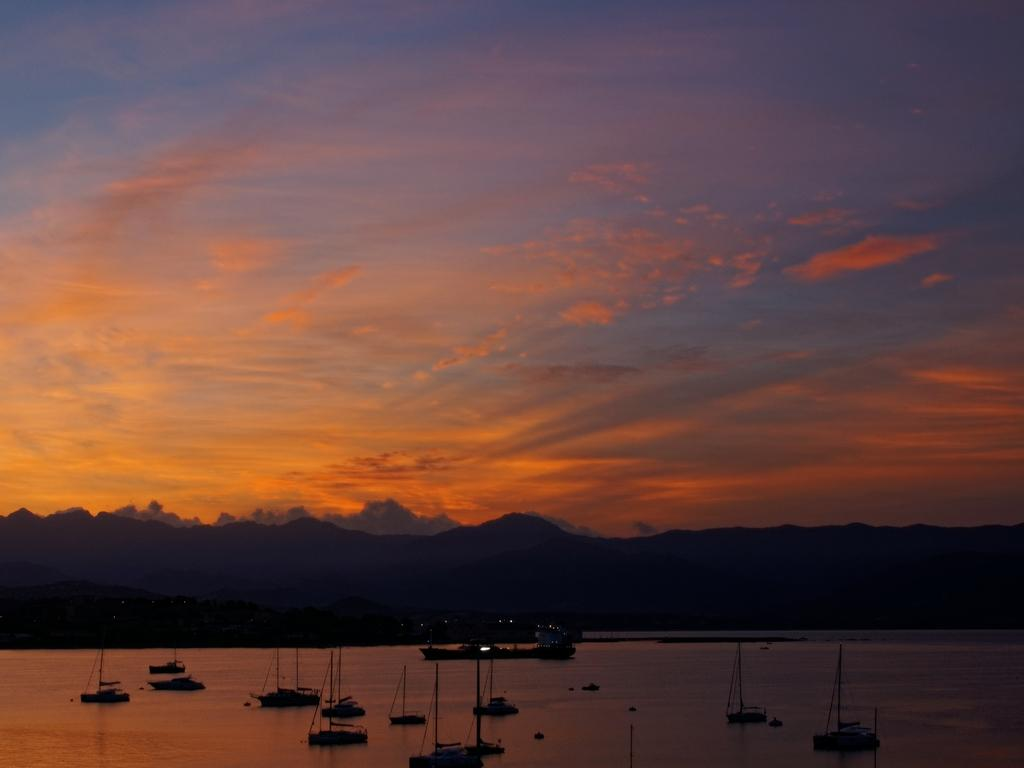What is the main event or scene depicted in the image? The image depicts a sunset. What can be seen on the water surface in the image? There are ships on the water surface in the image. What is visible in the background of the image? There are mountains in the background of the image. Can you see anyone smiling or laughing in the image? There are no people present in the image, so it is not possible to see anyone smiling or laughing. 